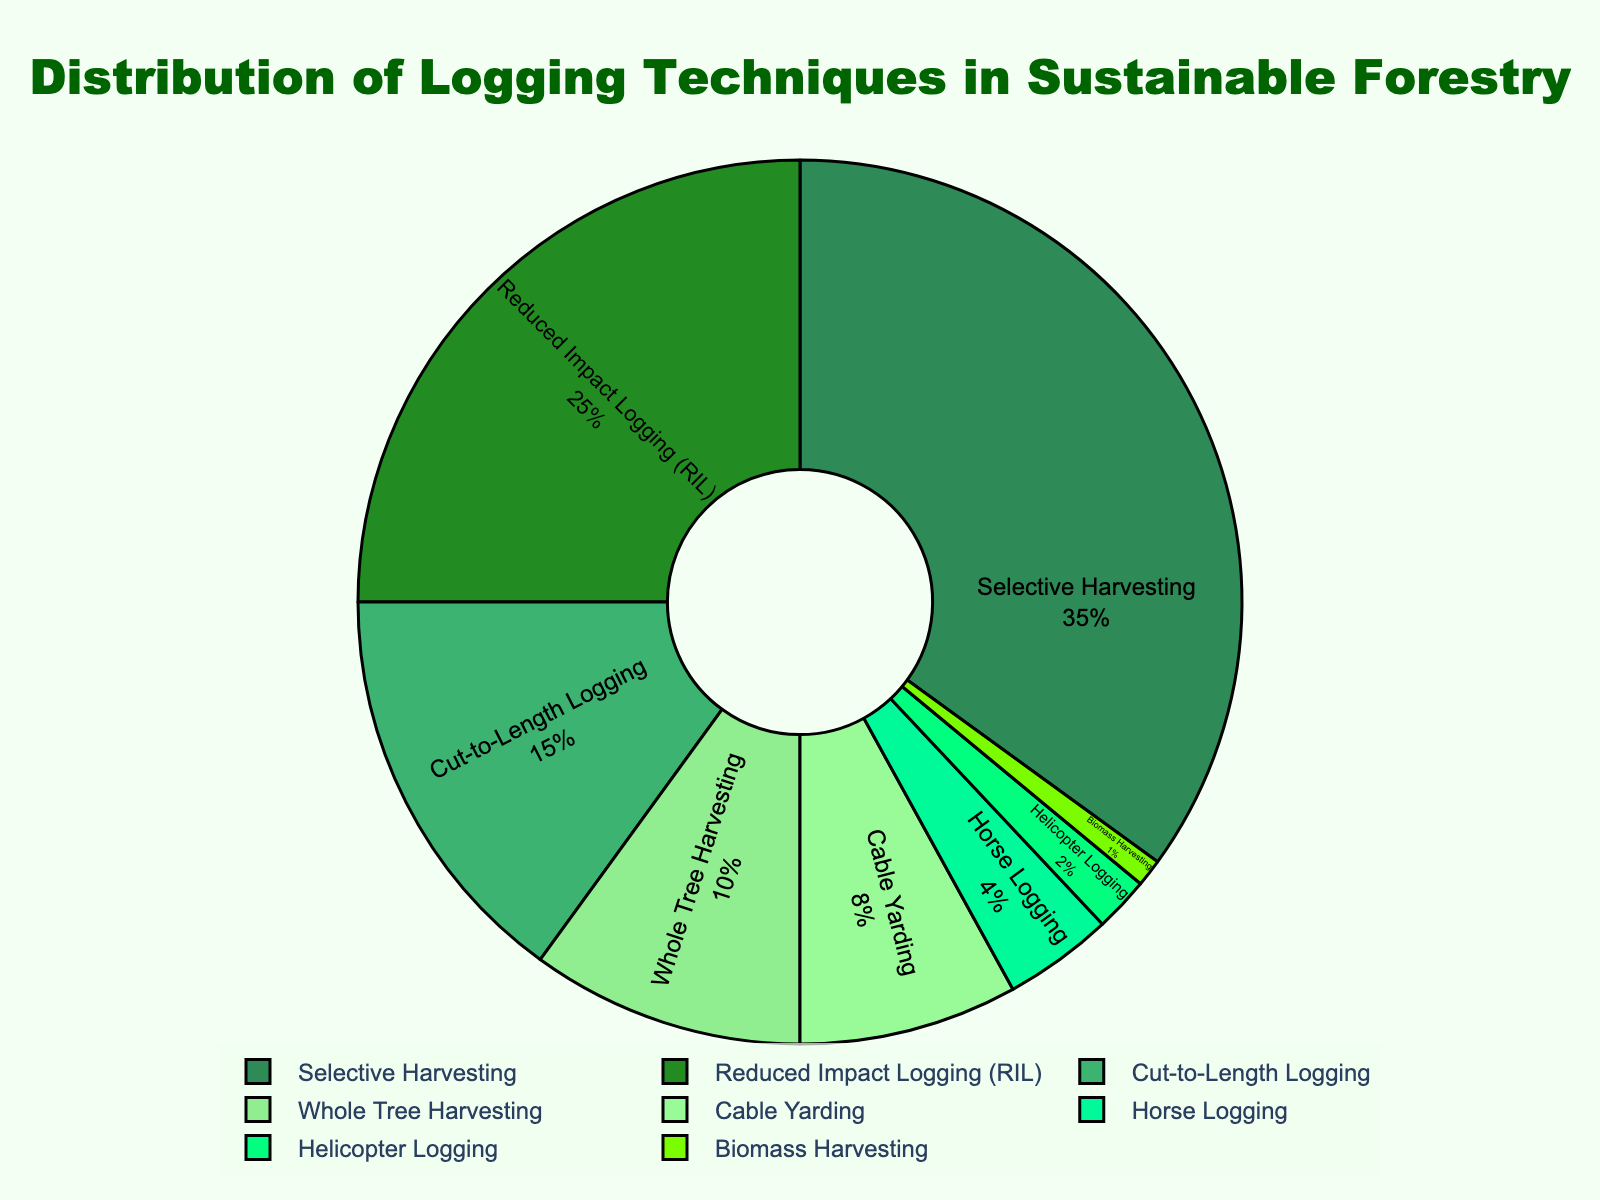What's the percentage for Selective Harvesting compared to Reduced Impact Logging (RIL)? The figure shows percentages for each logging technique. Selective Harvesting is at 35% and RIL is at 25%. By comparing these, we see Selective Harvesting has 10% more than RIL.
Answer: 10% Which logging technique has the highest percentage? The figure represents the distribution of multiple logging techniques. By looking at the labels and their percentages, Selective Harvesting has the highest with 35%.
Answer: Selective Harvesting What is the combined percentage of Cable Yarding and Horse Logging? Locate the percentages for Cable Yarding (8%) and Horse Logging (4%) on the pie chart. Adding these together gives 8% + 4% = 12%.
Answer: 12% What is the most used logging technique that is least common after Cable Yarding? From the chart, the technique used less frequently than Cable Yarding (8%) but more frequently than any other techniques after it is Horse Logging (4%).
Answer: Horse Logging What's the ratio of Whole Tree Harvesting to Helicopter Logging? The pie chart shows 10% for Whole Tree Harvesting and 2% for Helicopter Logging. The ratio is 10% to 2%, simplifying to 5 to 1.
Answer: 5:1 If you sum the percentages of the three least used techniques, what do you get? Identify the three least used techniques: Biomass Harvesting (1%), Helicopter Logging (2%), and Horse Logging (4%). Sum them: 1% + 2% + 4% = 7%.
Answer: 7% What percentage of techniques contribute less than 10% each? Techniques contributing less than 10% are Whole Tree Harvesting (10%), Cable Yarding (8%), Horse Logging (4%), Helicopter Logging (2%), and Biomass Harvesting (1%). Sum these: 8% + 4% + 2% + 1% = 15%.
Answer: 15% Which two techniques combined make up 40% of the total percentage? Reviewing the percentages: Selective Harvesting (35%) and Cut-to-Length Logging (15%). Summing these: 35% + 15% = 40%.
Answer: Selective Harvesting and Cut-to-Length Logging What is the difference in percentage between the most and least used techniques? The most used technique is Selective Harvesting (35%) and the least used is Biomass Harvesting (1%). The difference is 35% - 1% = 34%.
Answer: 34% If you add together the percentages of Reduced Impact Logging (RIL) and both the techniques with 10% and 15%, which percentage do you get? RIL is 25%, Whole Tree Harvesting is 10%, and Cut-to-Length Logging is 15%. Adding these: 25% + 10% + 15% = 50%.
Answer: 50% 